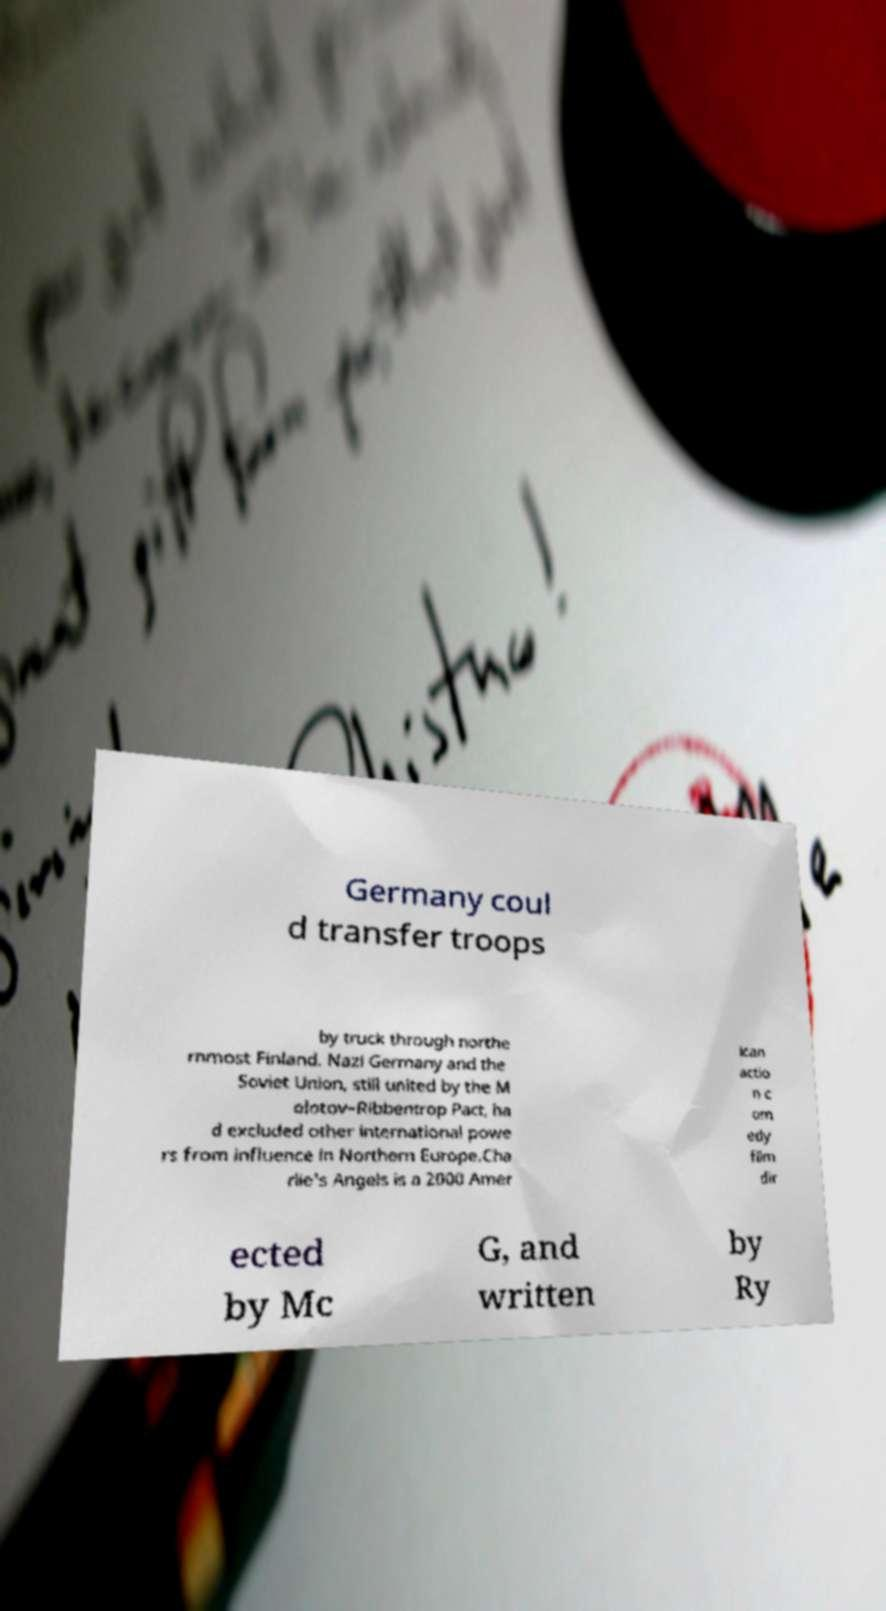Can you read and provide the text displayed in the image?This photo seems to have some interesting text. Can you extract and type it out for me? Germany coul d transfer troops by truck through northe rnmost Finland. Nazi Germany and the Soviet Union, still united by the M olotov–Ribbentrop Pact, ha d excluded other international powe rs from influence in Northern Europe.Cha rlie's Angels is a 2000 Amer ican actio n c om edy film dir ected by Mc G, and written by Ry 